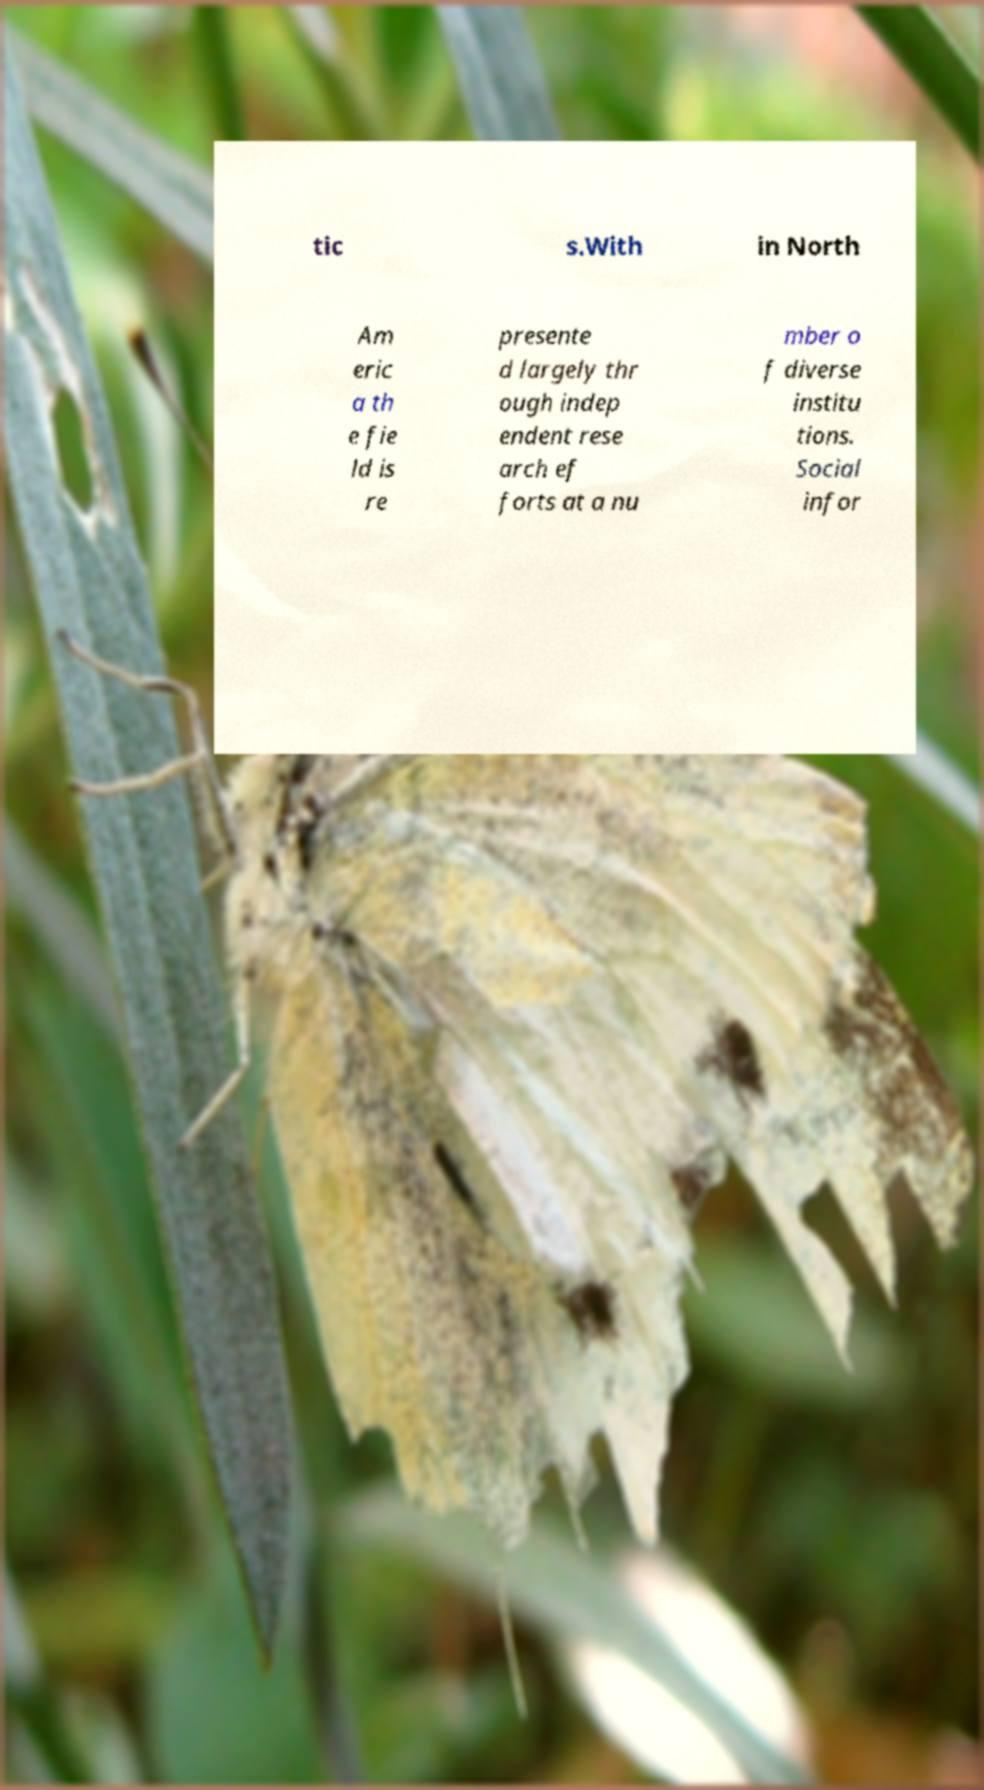Could you assist in decoding the text presented in this image and type it out clearly? tic s.With in North Am eric a th e fie ld is re presente d largely thr ough indep endent rese arch ef forts at a nu mber o f diverse institu tions. Social infor 